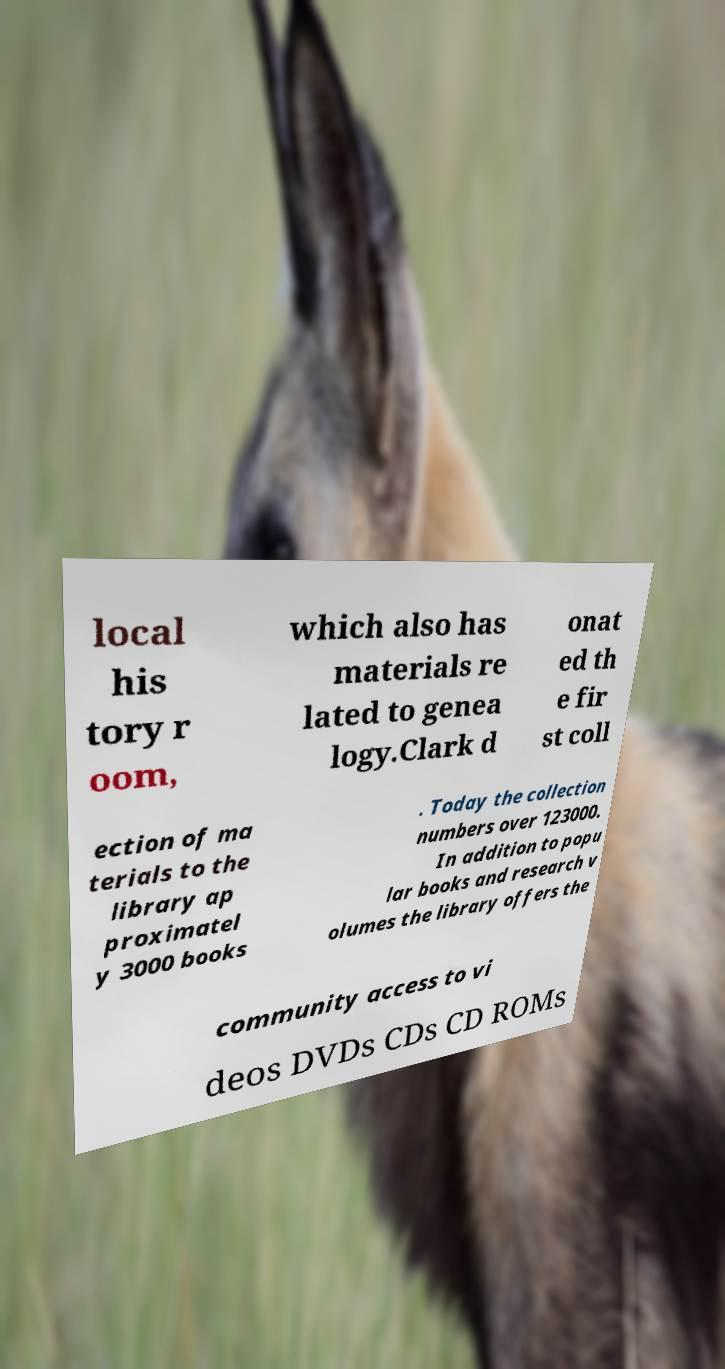For documentation purposes, I need the text within this image transcribed. Could you provide that? local his tory r oom, which also has materials re lated to genea logy.Clark d onat ed th e fir st coll ection of ma terials to the library ap proximatel y 3000 books . Today the collection numbers over 123000. In addition to popu lar books and research v olumes the library offers the community access to vi deos DVDs CDs CD ROMs 